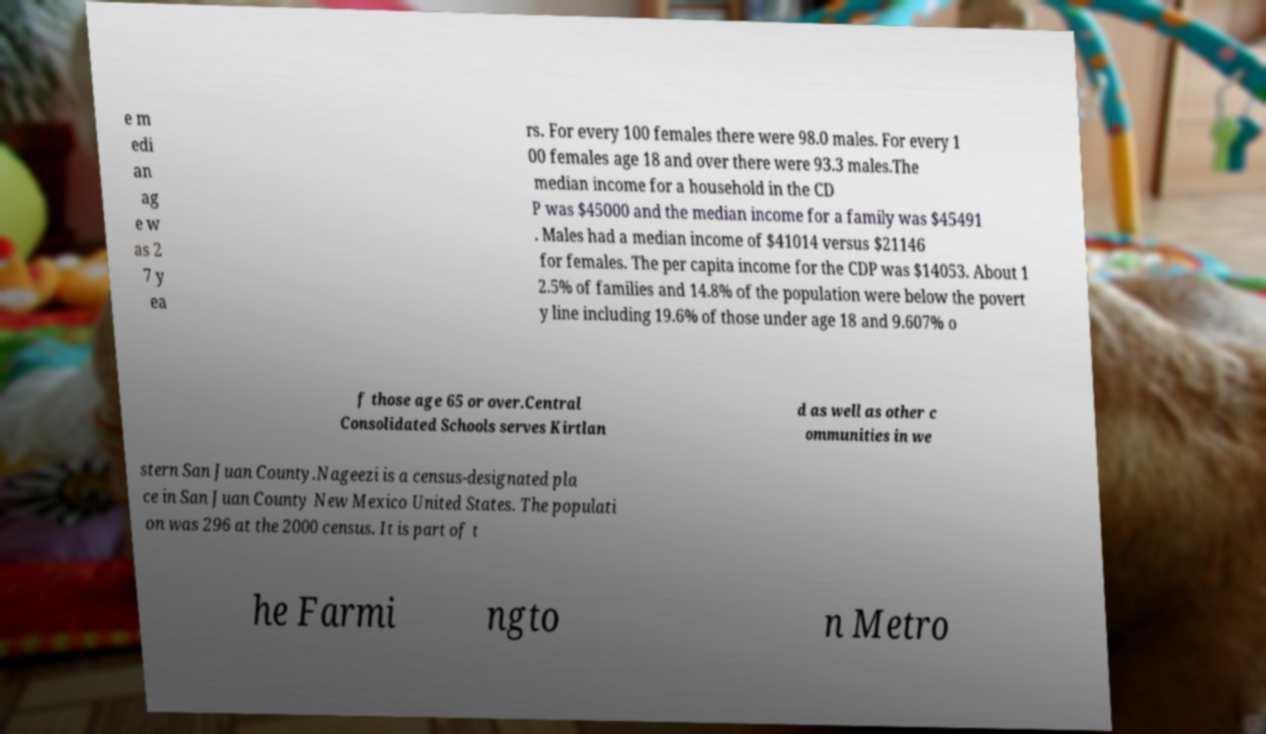Could you assist in decoding the text presented in this image and type it out clearly? e m edi an ag e w as 2 7 y ea rs. For every 100 females there were 98.0 males. For every 1 00 females age 18 and over there were 93.3 males.The median income for a household in the CD P was $45000 and the median income for a family was $45491 . Males had a median income of $41014 versus $21146 for females. The per capita income for the CDP was $14053. About 1 2.5% of families and 14.8% of the population were below the povert y line including 19.6% of those under age 18 and 9.607% o f those age 65 or over.Central Consolidated Schools serves Kirtlan d as well as other c ommunities in we stern San Juan County.Nageezi is a census-designated pla ce in San Juan County New Mexico United States. The populati on was 296 at the 2000 census. It is part of t he Farmi ngto n Metro 